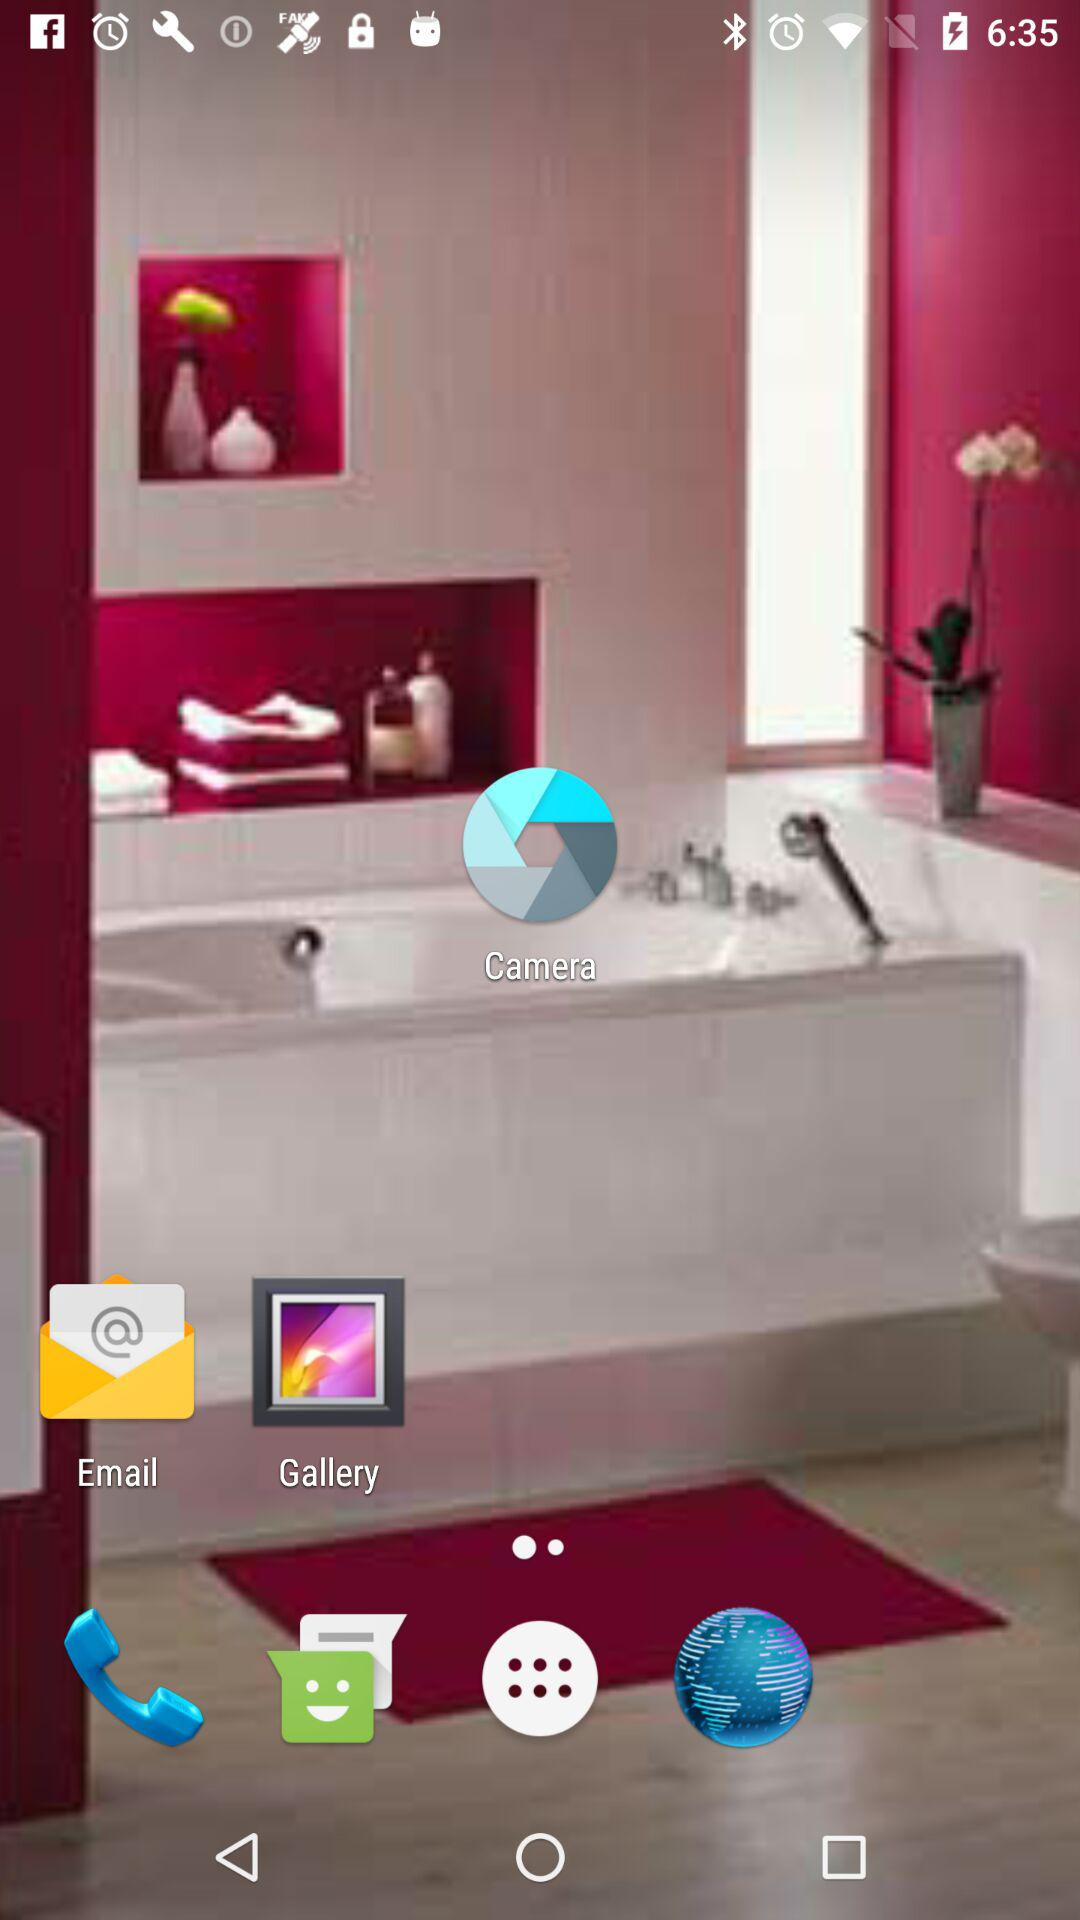How many more reviews does the app have than downloads?
Answer the question using a single word or phrase. 69 million 